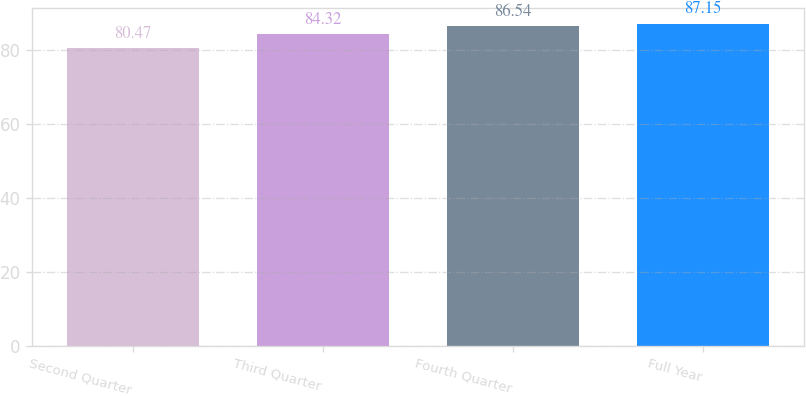<chart> <loc_0><loc_0><loc_500><loc_500><bar_chart><fcel>Second Quarter<fcel>Third Quarter<fcel>Fourth Quarter<fcel>Full Year<nl><fcel>80.47<fcel>84.32<fcel>86.54<fcel>87.15<nl></chart> 